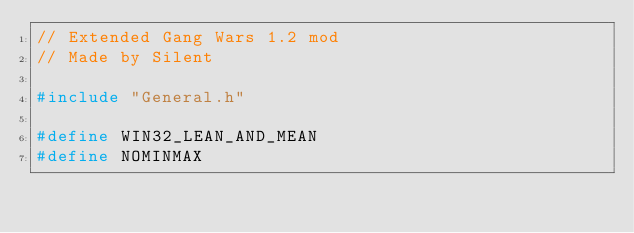<code> <loc_0><loc_0><loc_500><loc_500><_C++_>// Extended Gang Wars 1.2 mod
// Made by Silent

#include "General.h"

#define WIN32_LEAN_AND_MEAN
#define NOMINMAX
</code> 